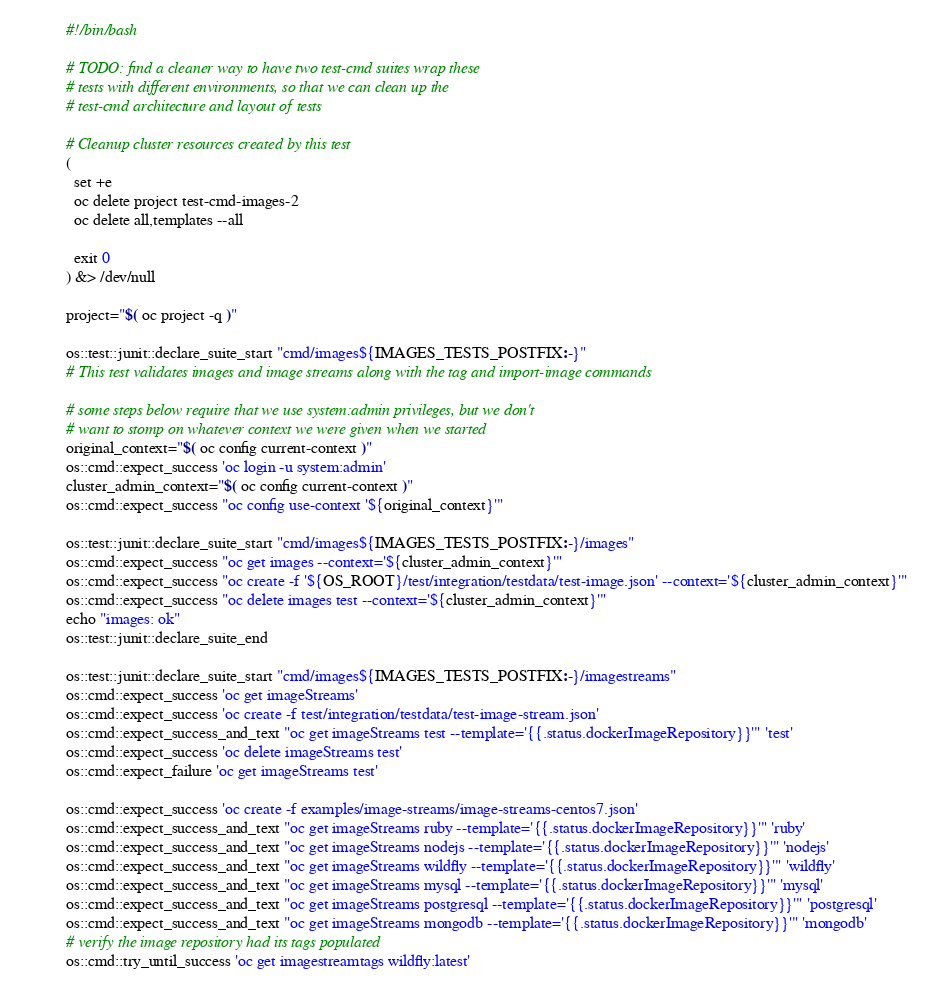Convert code to text. <code><loc_0><loc_0><loc_500><loc_500><_Bash_>#!/bin/bash

# TODO: find a cleaner way to have two test-cmd suites wrap these
# tests with different environments, so that we can clean up the
# test-cmd architecture and layout of tests

# Cleanup cluster resources created by this test
(
  set +e
  oc delete project test-cmd-images-2
  oc delete all,templates --all

  exit 0
) &> /dev/null

project="$( oc project -q )"

os::test::junit::declare_suite_start "cmd/images${IMAGES_TESTS_POSTFIX:-}"
# This test validates images and image streams along with the tag and import-image commands

# some steps below require that we use system:admin privileges, but we don't
# want to stomp on whatever context we were given when we started
original_context="$( oc config current-context )"
os::cmd::expect_success 'oc login -u system:admin'
cluster_admin_context="$( oc config current-context )"
os::cmd::expect_success "oc config use-context '${original_context}'"

os::test::junit::declare_suite_start "cmd/images${IMAGES_TESTS_POSTFIX:-}/images"
os::cmd::expect_success "oc get images --context='${cluster_admin_context}'"
os::cmd::expect_success "oc create -f '${OS_ROOT}/test/integration/testdata/test-image.json' --context='${cluster_admin_context}'"
os::cmd::expect_success "oc delete images test --context='${cluster_admin_context}'"
echo "images: ok"
os::test::junit::declare_suite_end

os::test::junit::declare_suite_start "cmd/images${IMAGES_TESTS_POSTFIX:-}/imagestreams"
os::cmd::expect_success 'oc get imageStreams'
os::cmd::expect_success 'oc create -f test/integration/testdata/test-image-stream.json'
os::cmd::expect_success_and_text "oc get imageStreams test --template='{{.status.dockerImageRepository}}'" 'test'
os::cmd::expect_success 'oc delete imageStreams test'
os::cmd::expect_failure 'oc get imageStreams test'

os::cmd::expect_success 'oc create -f examples/image-streams/image-streams-centos7.json'
os::cmd::expect_success_and_text "oc get imageStreams ruby --template='{{.status.dockerImageRepository}}'" 'ruby'
os::cmd::expect_success_and_text "oc get imageStreams nodejs --template='{{.status.dockerImageRepository}}'" 'nodejs'
os::cmd::expect_success_and_text "oc get imageStreams wildfly --template='{{.status.dockerImageRepository}}'" 'wildfly'
os::cmd::expect_success_and_text "oc get imageStreams mysql --template='{{.status.dockerImageRepository}}'" 'mysql'
os::cmd::expect_success_and_text "oc get imageStreams postgresql --template='{{.status.dockerImageRepository}}'" 'postgresql'
os::cmd::expect_success_and_text "oc get imageStreams mongodb --template='{{.status.dockerImageRepository}}'" 'mongodb'
# verify the image repository had its tags populated
os::cmd::try_until_success 'oc get imagestreamtags wildfly:latest'</code> 